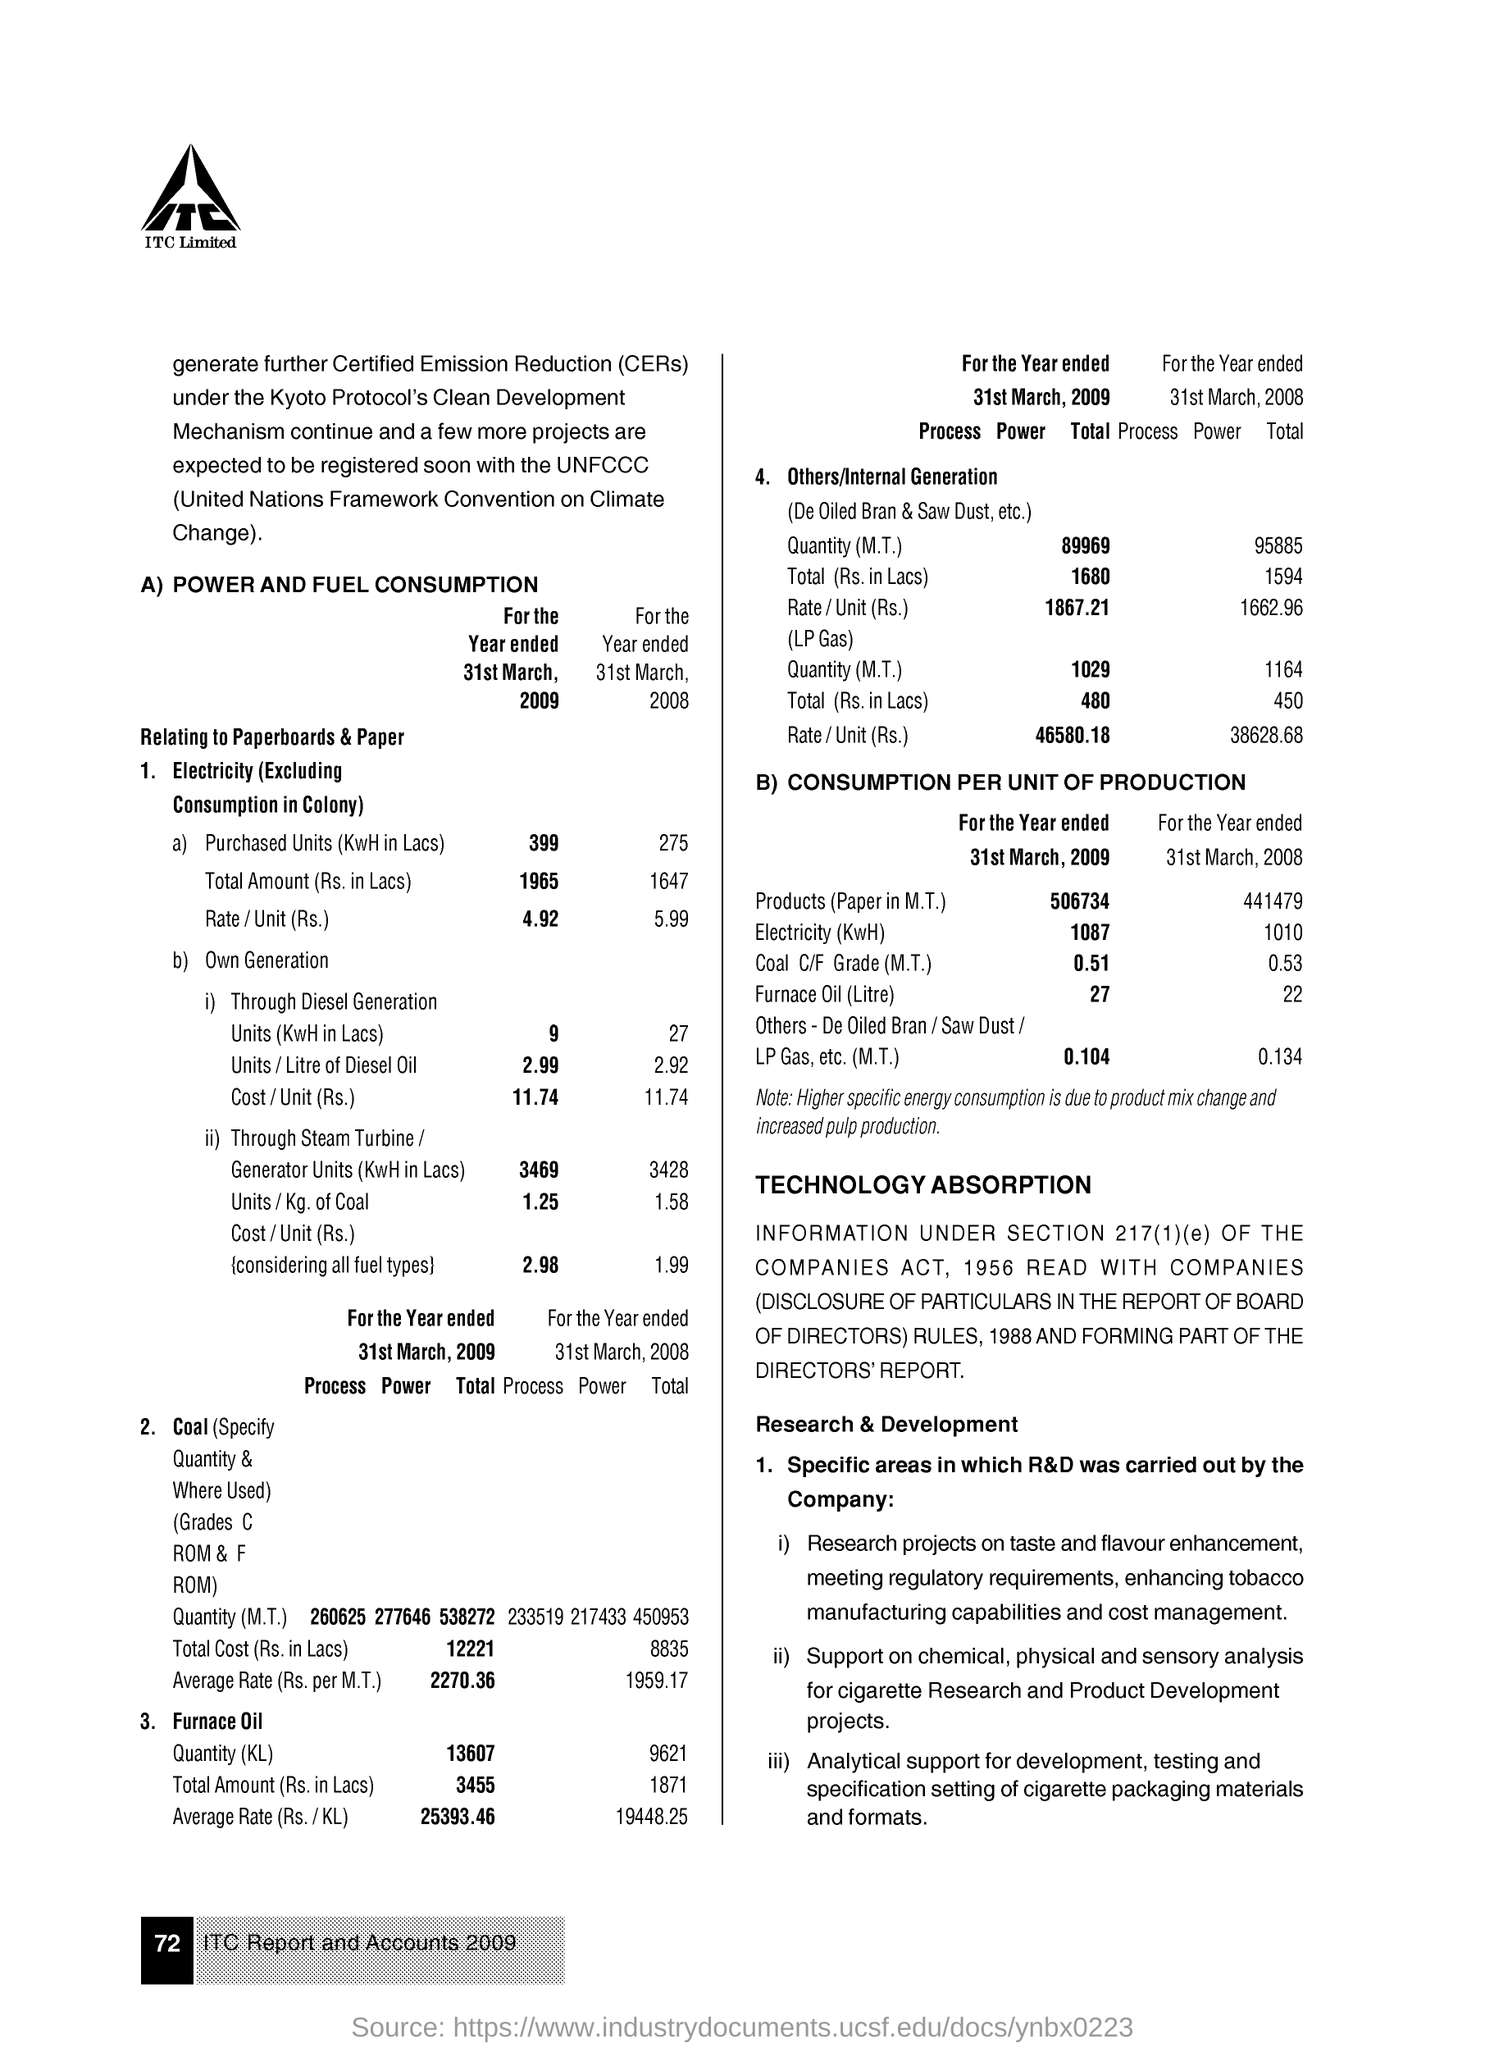How many units of electricity is purchased in 31st March, 2009 ?
Your answer should be compact. 399. What is the electricity rate/unit(rs.) in 31st march, 2009 ?
Ensure brevity in your answer.  4.92. How many units of electricity is produced  through steam Turbine/Generator in 31st March, 2009 ?
Offer a terse response. 3469. 